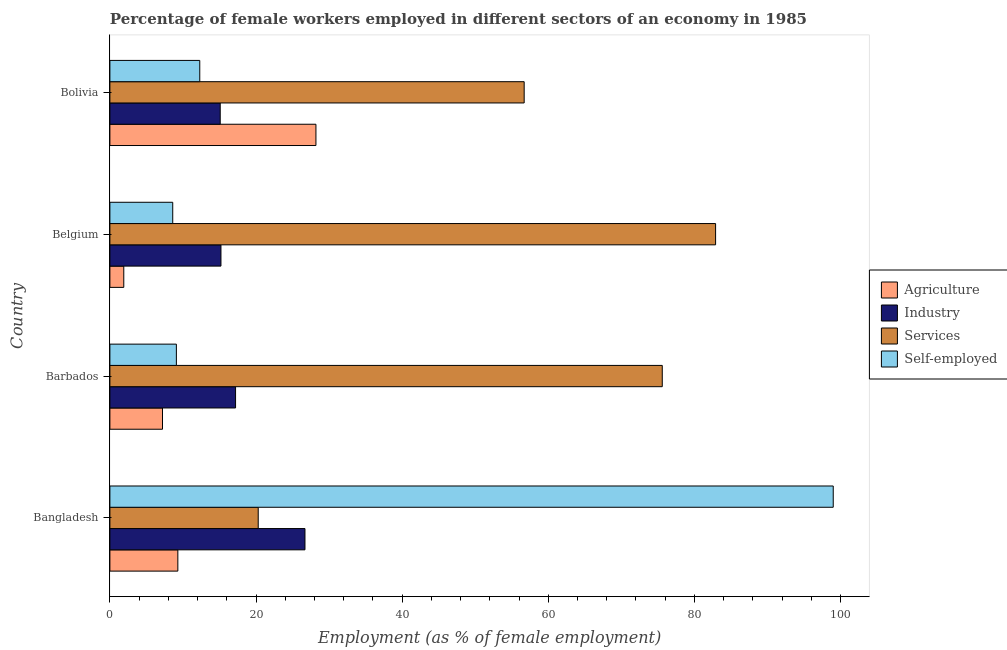How many different coloured bars are there?
Keep it short and to the point. 4. Are the number of bars on each tick of the Y-axis equal?
Keep it short and to the point. Yes. How many bars are there on the 3rd tick from the top?
Ensure brevity in your answer.  4. How many bars are there on the 2nd tick from the bottom?
Provide a short and direct response. 4. In how many cases, is the number of bars for a given country not equal to the number of legend labels?
Ensure brevity in your answer.  0. What is the percentage of female workers in services in Bolivia?
Offer a terse response. 56.7. Across all countries, what is the maximum percentage of female workers in services?
Ensure brevity in your answer.  82.9. Across all countries, what is the minimum percentage of female workers in agriculture?
Your response must be concise. 1.9. In which country was the percentage of female workers in industry maximum?
Make the answer very short. Bangladesh. What is the total percentage of female workers in industry in the graph?
Your response must be concise. 74.2. What is the difference between the percentage of female workers in services in Belgium and that in Bolivia?
Your answer should be compact. 26.2. What is the difference between the percentage of female workers in agriculture in Barbados and the percentage of female workers in industry in Belgium?
Keep it short and to the point. -8. What is the average percentage of self employed female workers per country?
Offer a terse response. 32.25. What is the ratio of the percentage of female workers in services in Barbados to that in Bolivia?
Provide a short and direct response. 1.33. Is the difference between the percentage of female workers in industry in Belgium and Bolivia greater than the difference between the percentage of self employed female workers in Belgium and Bolivia?
Offer a terse response. Yes. What is the difference between the highest and the second highest percentage of self employed female workers?
Provide a short and direct response. 86.7. What is the difference between the highest and the lowest percentage of female workers in services?
Provide a succinct answer. 62.6. Is the sum of the percentage of female workers in agriculture in Belgium and Bolivia greater than the maximum percentage of female workers in industry across all countries?
Ensure brevity in your answer.  Yes. Is it the case that in every country, the sum of the percentage of female workers in industry and percentage of self employed female workers is greater than the sum of percentage of female workers in agriculture and percentage of female workers in services?
Your answer should be compact. Yes. What does the 1st bar from the top in Bolivia represents?
Your answer should be very brief. Self-employed. What does the 2nd bar from the bottom in Belgium represents?
Offer a terse response. Industry. Does the graph contain any zero values?
Ensure brevity in your answer.  No. Does the graph contain grids?
Provide a succinct answer. No. Where does the legend appear in the graph?
Provide a short and direct response. Center right. How many legend labels are there?
Make the answer very short. 4. What is the title of the graph?
Provide a short and direct response. Percentage of female workers employed in different sectors of an economy in 1985. What is the label or title of the X-axis?
Provide a short and direct response. Employment (as % of female employment). What is the label or title of the Y-axis?
Offer a very short reply. Country. What is the Employment (as % of female employment) in Agriculture in Bangladesh?
Give a very brief answer. 9.3. What is the Employment (as % of female employment) in Industry in Bangladesh?
Provide a succinct answer. 26.7. What is the Employment (as % of female employment) of Services in Bangladesh?
Give a very brief answer. 20.3. What is the Employment (as % of female employment) in Agriculture in Barbados?
Offer a very short reply. 7.2. What is the Employment (as % of female employment) in Industry in Barbados?
Give a very brief answer. 17.2. What is the Employment (as % of female employment) in Services in Barbados?
Offer a very short reply. 75.6. What is the Employment (as % of female employment) in Self-employed in Barbados?
Provide a short and direct response. 9.1. What is the Employment (as % of female employment) of Agriculture in Belgium?
Your answer should be very brief. 1.9. What is the Employment (as % of female employment) of Industry in Belgium?
Your response must be concise. 15.2. What is the Employment (as % of female employment) in Services in Belgium?
Ensure brevity in your answer.  82.9. What is the Employment (as % of female employment) in Self-employed in Belgium?
Your response must be concise. 8.6. What is the Employment (as % of female employment) of Agriculture in Bolivia?
Offer a very short reply. 28.2. What is the Employment (as % of female employment) of Industry in Bolivia?
Give a very brief answer. 15.1. What is the Employment (as % of female employment) of Services in Bolivia?
Make the answer very short. 56.7. What is the Employment (as % of female employment) of Self-employed in Bolivia?
Make the answer very short. 12.3. Across all countries, what is the maximum Employment (as % of female employment) of Agriculture?
Offer a very short reply. 28.2. Across all countries, what is the maximum Employment (as % of female employment) in Industry?
Offer a terse response. 26.7. Across all countries, what is the maximum Employment (as % of female employment) of Services?
Make the answer very short. 82.9. Across all countries, what is the minimum Employment (as % of female employment) in Agriculture?
Offer a terse response. 1.9. Across all countries, what is the minimum Employment (as % of female employment) of Industry?
Make the answer very short. 15.1. Across all countries, what is the minimum Employment (as % of female employment) of Services?
Provide a succinct answer. 20.3. Across all countries, what is the minimum Employment (as % of female employment) of Self-employed?
Your response must be concise. 8.6. What is the total Employment (as % of female employment) in Agriculture in the graph?
Provide a succinct answer. 46.6. What is the total Employment (as % of female employment) in Industry in the graph?
Offer a very short reply. 74.2. What is the total Employment (as % of female employment) of Services in the graph?
Your response must be concise. 235.5. What is the total Employment (as % of female employment) in Self-employed in the graph?
Make the answer very short. 129. What is the difference between the Employment (as % of female employment) of Agriculture in Bangladesh and that in Barbados?
Provide a short and direct response. 2.1. What is the difference between the Employment (as % of female employment) in Services in Bangladesh and that in Barbados?
Offer a terse response. -55.3. What is the difference between the Employment (as % of female employment) of Self-employed in Bangladesh and that in Barbados?
Offer a very short reply. 89.9. What is the difference between the Employment (as % of female employment) of Services in Bangladesh and that in Belgium?
Provide a short and direct response. -62.6. What is the difference between the Employment (as % of female employment) in Self-employed in Bangladesh and that in Belgium?
Provide a succinct answer. 90.4. What is the difference between the Employment (as % of female employment) of Agriculture in Bangladesh and that in Bolivia?
Provide a short and direct response. -18.9. What is the difference between the Employment (as % of female employment) of Industry in Bangladesh and that in Bolivia?
Make the answer very short. 11.6. What is the difference between the Employment (as % of female employment) in Services in Bangladesh and that in Bolivia?
Keep it short and to the point. -36.4. What is the difference between the Employment (as % of female employment) of Self-employed in Bangladesh and that in Bolivia?
Provide a short and direct response. 86.7. What is the difference between the Employment (as % of female employment) in Agriculture in Barbados and that in Belgium?
Your answer should be very brief. 5.3. What is the difference between the Employment (as % of female employment) of Industry in Barbados and that in Belgium?
Give a very brief answer. 2. What is the difference between the Employment (as % of female employment) in Agriculture in Barbados and that in Bolivia?
Provide a succinct answer. -21. What is the difference between the Employment (as % of female employment) in Services in Barbados and that in Bolivia?
Your response must be concise. 18.9. What is the difference between the Employment (as % of female employment) of Self-employed in Barbados and that in Bolivia?
Give a very brief answer. -3.2. What is the difference between the Employment (as % of female employment) in Agriculture in Belgium and that in Bolivia?
Your answer should be compact. -26.3. What is the difference between the Employment (as % of female employment) in Services in Belgium and that in Bolivia?
Your answer should be very brief. 26.2. What is the difference between the Employment (as % of female employment) in Agriculture in Bangladesh and the Employment (as % of female employment) in Industry in Barbados?
Your response must be concise. -7.9. What is the difference between the Employment (as % of female employment) of Agriculture in Bangladesh and the Employment (as % of female employment) of Services in Barbados?
Keep it short and to the point. -66.3. What is the difference between the Employment (as % of female employment) in Agriculture in Bangladesh and the Employment (as % of female employment) in Self-employed in Barbados?
Your answer should be very brief. 0.2. What is the difference between the Employment (as % of female employment) in Industry in Bangladesh and the Employment (as % of female employment) in Services in Barbados?
Your response must be concise. -48.9. What is the difference between the Employment (as % of female employment) in Services in Bangladesh and the Employment (as % of female employment) in Self-employed in Barbados?
Your answer should be very brief. 11.2. What is the difference between the Employment (as % of female employment) in Agriculture in Bangladesh and the Employment (as % of female employment) in Services in Belgium?
Offer a terse response. -73.6. What is the difference between the Employment (as % of female employment) of Agriculture in Bangladesh and the Employment (as % of female employment) of Self-employed in Belgium?
Provide a short and direct response. 0.7. What is the difference between the Employment (as % of female employment) of Industry in Bangladesh and the Employment (as % of female employment) of Services in Belgium?
Provide a succinct answer. -56.2. What is the difference between the Employment (as % of female employment) in Industry in Bangladesh and the Employment (as % of female employment) in Self-employed in Belgium?
Give a very brief answer. 18.1. What is the difference between the Employment (as % of female employment) of Services in Bangladesh and the Employment (as % of female employment) of Self-employed in Belgium?
Make the answer very short. 11.7. What is the difference between the Employment (as % of female employment) of Agriculture in Bangladesh and the Employment (as % of female employment) of Industry in Bolivia?
Keep it short and to the point. -5.8. What is the difference between the Employment (as % of female employment) in Agriculture in Bangladesh and the Employment (as % of female employment) in Services in Bolivia?
Keep it short and to the point. -47.4. What is the difference between the Employment (as % of female employment) of Agriculture in Bangladesh and the Employment (as % of female employment) of Self-employed in Bolivia?
Offer a terse response. -3. What is the difference between the Employment (as % of female employment) in Services in Bangladesh and the Employment (as % of female employment) in Self-employed in Bolivia?
Offer a terse response. 8. What is the difference between the Employment (as % of female employment) of Agriculture in Barbados and the Employment (as % of female employment) of Services in Belgium?
Keep it short and to the point. -75.7. What is the difference between the Employment (as % of female employment) in Industry in Barbados and the Employment (as % of female employment) in Services in Belgium?
Your response must be concise. -65.7. What is the difference between the Employment (as % of female employment) of Agriculture in Barbados and the Employment (as % of female employment) of Industry in Bolivia?
Offer a very short reply. -7.9. What is the difference between the Employment (as % of female employment) of Agriculture in Barbados and the Employment (as % of female employment) of Services in Bolivia?
Ensure brevity in your answer.  -49.5. What is the difference between the Employment (as % of female employment) in Agriculture in Barbados and the Employment (as % of female employment) in Self-employed in Bolivia?
Offer a very short reply. -5.1. What is the difference between the Employment (as % of female employment) in Industry in Barbados and the Employment (as % of female employment) in Services in Bolivia?
Your response must be concise. -39.5. What is the difference between the Employment (as % of female employment) in Industry in Barbados and the Employment (as % of female employment) in Self-employed in Bolivia?
Provide a short and direct response. 4.9. What is the difference between the Employment (as % of female employment) of Services in Barbados and the Employment (as % of female employment) of Self-employed in Bolivia?
Offer a terse response. 63.3. What is the difference between the Employment (as % of female employment) of Agriculture in Belgium and the Employment (as % of female employment) of Services in Bolivia?
Your answer should be very brief. -54.8. What is the difference between the Employment (as % of female employment) of Agriculture in Belgium and the Employment (as % of female employment) of Self-employed in Bolivia?
Offer a terse response. -10.4. What is the difference between the Employment (as % of female employment) of Industry in Belgium and the Employment (as % of female employment) of Services in Bolivia?
Make the answer very short. -41.5. What is the difference between the Employment (as % of female employment) in Industry in Belgium and the Employment (as % of female employment) in Self-employed in Bolivia?
Your answer should be compact. 2.9. What is the difference between the Employment (as % of female employment) in Services in Belgium and the Employment (as % of female employment) in Self-employed in Bolivia?
Your answer should be very brief. 70.6. What is the average Employment (as % of female employment) of Agriculture per country?
Make the answer very short. 11.65. What is the average Employment (as % of female employment) of Industry per country?
Keep it short and to the point. 18.55. What is the average Employment (as % of female employment) in Services per country?
Keep it short and to the point. 58.88. What is the average Employment (as % of female employment) in Self-employed per country?
Provide a succinct answer. 32.25. What is the difference between the Employment (as % of female employment) of Agriculture and Employment (as % of female employment) of Industry in Bangladesh?
Your answer should be very brief. -17.4. What is the difference between the Employment (as % of female employment) in Agriculture and Employment (as % of female employment) in Services in Bangladesh?
Offer a very short reply. -11. What is the difference between the Employment (as % of female employment) of Agriculture and Employment (as % of female employment) of Self-employed in Bangladesh?
Keep it short and to the point. -89.7. What is the difference between the Employment (as % of female employment) of Industry and Employment (as % of female employment) of Self-employed in Bangladesh?
Offer a very short reply. -72.3. What is the difference between the Employment (as % of female employment) in Services and Employment (as % of female employment) in Self-employed in Bangladesh?
Your response must be concise. -78.7. What is the difference between the Employment (as % of female employment) of Agriculture and Employment (as % of female employment) of Industry in Barbados?
Your response must be concise. -10. What is the difference between the Employment (as % of female employment) of Agriculture and Employment (as % of female employment) of Services in Barbados?
Keep it short and to the point. -68.4. What is the difference between the Employment (as % of female employment) of Industry and Employment (as % of female employment) of Services in Barbados?
Your answer should be compact. -58.4. What is the difference between the Employment (as % of female employment) of Services and Employment (as % of female employment) of Self-employed in Barbados?
Keep it short and to the point. 66.5. What is the difference between the Employment (as % of female employment) in Agriculture and Employment (as % of female employment) in Services in Belgium?
Provide a succinct answer. -81. What is the difference between the Employment (as % of female employment) in Agriculture and Employment (as % of female employment) in Self-employed in Belgium?
Keep it short and to the point. -6.7. What is the difference between the Employment (as % of female employment) in Industry and Employment (as % of female employment) in Services in Belgium?
Provide a succinct answer. -67.7. What is the difference between the Employment (as % of female employment) in Industry and Employment (as % of female employment) in Self-employed in Belgium?
Provide a succinct answer. 6.6. What is the difference between the Employment (as % of female employment) of Services and Employment (as % of female employment) of Self-employed in Belgium?
Keep it short and to the point. 74.3. What is the difference between the Employment (as % of female employment) in Agriculture and Employment (as % of female employment) in Services in Bolivia?
Keep it short and to the point. -28.5. What is the difference between the Employment (as % of female employment) in Industry and Employment (as % of female employment) in Services in Bolivia?
Your response must be concise. -41.6. What is the difference between the Employment (as % of female employment) in Industry and Employment (as % of female employment) in Self-employed in Bolivia?
Provide a short and direct response. 2.8. What is the difference between the Employment (as % of female employment) in Services and Employment (as % of female employment) in Self-employed in Bolivia?
Give a very brief answer. 44.4. What is the ratio of the Employment (as % of female employment) of Agriculture in Bangladesh to that in Barbados?
Provide a succinct answer. 1.29. What is the ratio of the Employment (as % of female employment) in Industry in Bangladesh to that in Barbados?
Keep it short and to the point. 1.55. What is the ratio of the Employment (as % of female employment) of Services in Bangladesh to that in Barbados?
Offer a very short reply. 0.27. What is the ratio of the Employment (as % of female employment) of Self-employed in Bangladesh to that in Barbados?
Your response must be concise. 10.88. What is the ratio of the Employment (as % of female employment) of Agriculture in Bangladesh to that in Belgium?
Keep it short and to the point. 4.89. What is the ratio of the Employment (as % of female employment) of Industry in Bangladesh to that in Belgium?
Make the answer very short. 1.76. What is the ratio of the Employment (as % of female employment) in Services in Bangladesh to that in Belgium?
Ensure brevity in your answer.  0.24. What is the ratio of the Employment (as % of female employment) in Self-employed in Bangladesh to that in Belgium?
Provide a succinct answer. 11.51. What is the ratio of the Employment (as % of female employment) of Agriculture in Bangladesh to that in Bolivia?
Make the answer very short. 0.33. What is the ratio of the Employment (as % of female employment) in Industry in Bangladesh to that in Bolivia?
Keep it short and to the point. 1.77. What is the ratio of the Employment (as % of female employment) of Services in Bangladesh to that in Bolivia?
Your response must be concise. 0.36. What is the ratio of the Employment (as % of female employment) in Self-employed in Bangladesh to that in Bolivia?
Keep it short and to the point. 8.05. What is the ratio of the Employment (as % of female employment) in Agriculture in Barbados to that in Belgium?
Keep it short and to the point. 3.79. What is the ratio of the Employment (as % of female employment) of Industry in Barbados to that in Belgium?
Ensure brevity in your answer.  1.13. What is the ratio of the Employment (as % of female employment) of Services in Barbados to that in Belgium?
Offer a very short reply. 0.91. What is the ratio of the Employment (as % of female employment) of Self-employed in Barbados to that in Belgium?
Your answer should be compact. 1.06. What is the ratio of the Employment (as % of female employment) in Agriculture in Barbados to that in Bolivia?
Your answer should be very brief. 0.26. What is the ratio of the Employment (as % of female employment) of Industry in Barbados to that in Bolivia?
Provide a short and direct response. 1.14. What is the ratio of the Employment (as % of female employment) in Self-employed in Barbados to that in Bolivia?
Your response must be concise. 0.74. What is the ratio of the Employment (as % of female employment) of Agriculture in Belgium to that in Bolivia?
Provide a succinct answer. 0.07. What is the ratio of the Employment (as % of female employment) in Industry in Belgium to that in Bolivia?
Give a very brief answer. 1.01. What is the ratio of the Employment (as % of female employment) in Services in Belgium to that in Bolivia?
Provide a short and direct response. 1.46. What is the ratio of the Employment (as % of female employment) in Self-employed in Belgium to that in Bolivia?
Your answer should be compact. 0.7. What is the difference between the highest and the second highest Employment (as % of female employment) in Industry?
Your answer should be very brief. 9.5. What is the difference between the highest and the second highest Employment (as % of female employment) of Services?
Your answer should be very brief. 7.3. What is the difference between the highest and the second highest Employment (as % of female employment) of Self-employed?
Make the answer very short. 86.7. What is the difference between the highest and the lowest Employment (as % of female employment) in Agriculture?
Provide a short and direct response. 26.3. What is the difference between the highest and the lowest Employment (as % of female employment) in Industry?
Make the answer very short. 11.6. What is the difference between the highest and the lowest Employment (as % of female employment) of Services?
Make the answer very short. 62.6. What is the difference between the highest and the lowest Employment (as % of female employment) in Self-employed?
Keep it short and to the point. 90.4. 